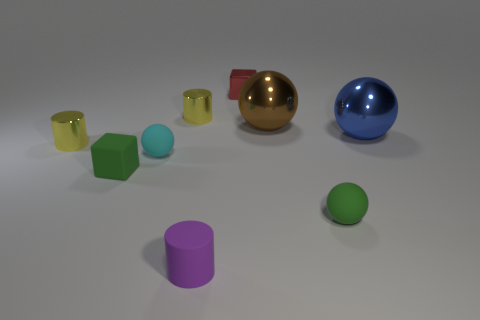Subtract all large blue shiny spheres. How many spheres are left? 3 Subtract all blue balls. How many balls are left? 3 Add 1 red cubes. How many objects exist? 10 Subtract all spheres. How many objects are left? 5 Subtract 2 balls. How many balls are left? 2 Subtract all red cubes. How many yellow cylinders are left? 2 Add 5 large blue metallic things. How many large blue metallic things are left? 6 Add 2 gray metallic cylinders. How many gray metallic cylinders exist? 2 Subtract 1 blue spheres. How many objects are left? 8 Subtract all gray balls. Subtract all red cubes. How many balls are left? 4 